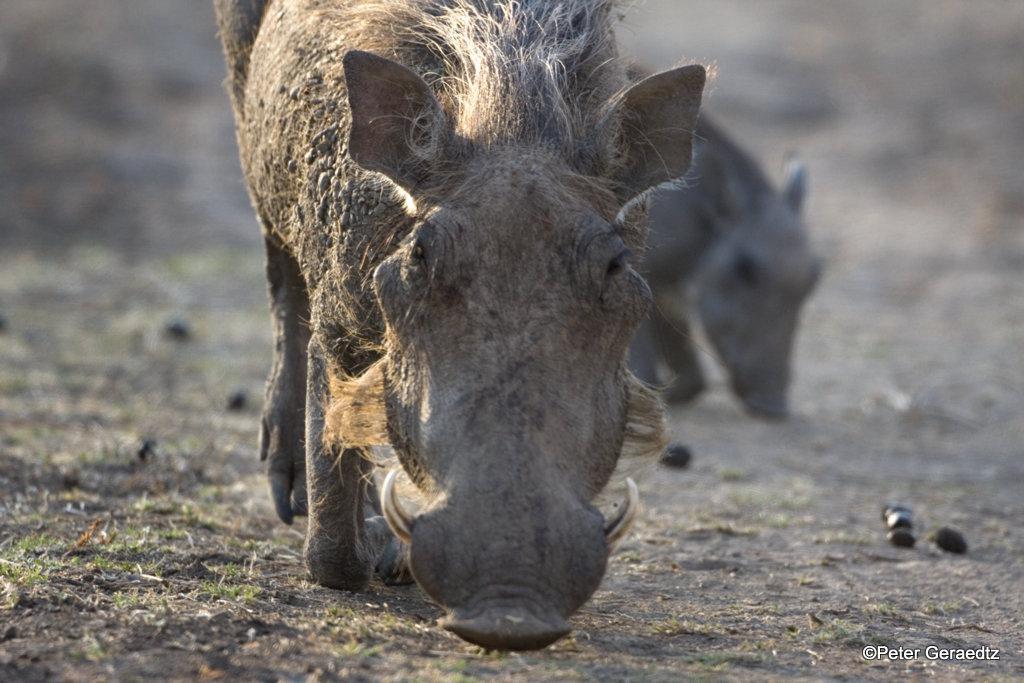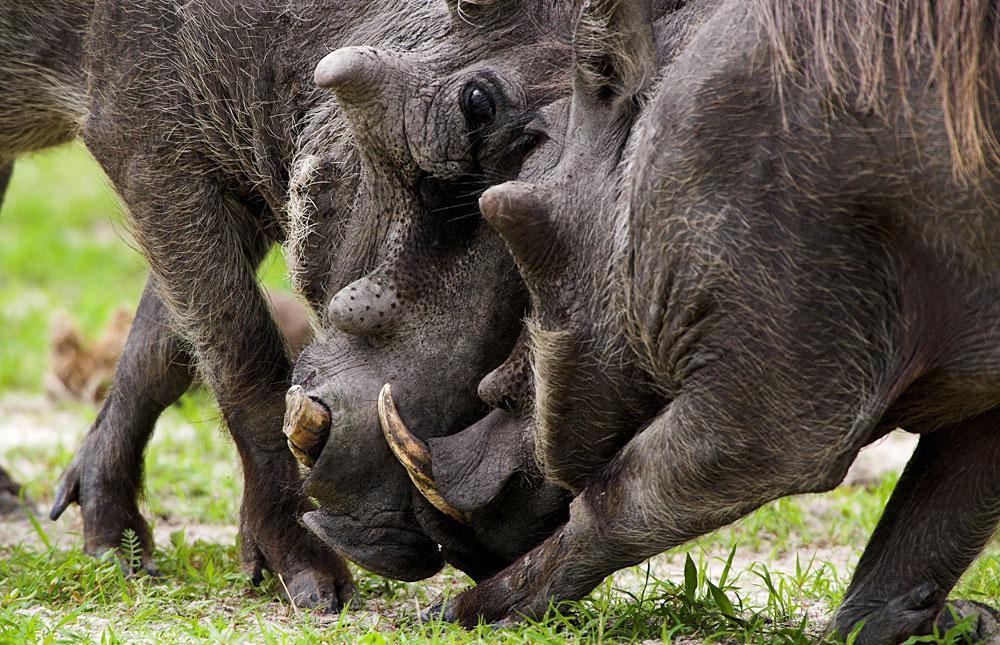The first image is the image on the left, the second image is the image on the right. For the images displayed, is the sentence "A hog's leg is bleeding while it fights another hog." factually correct? Answer yes or no. No. 